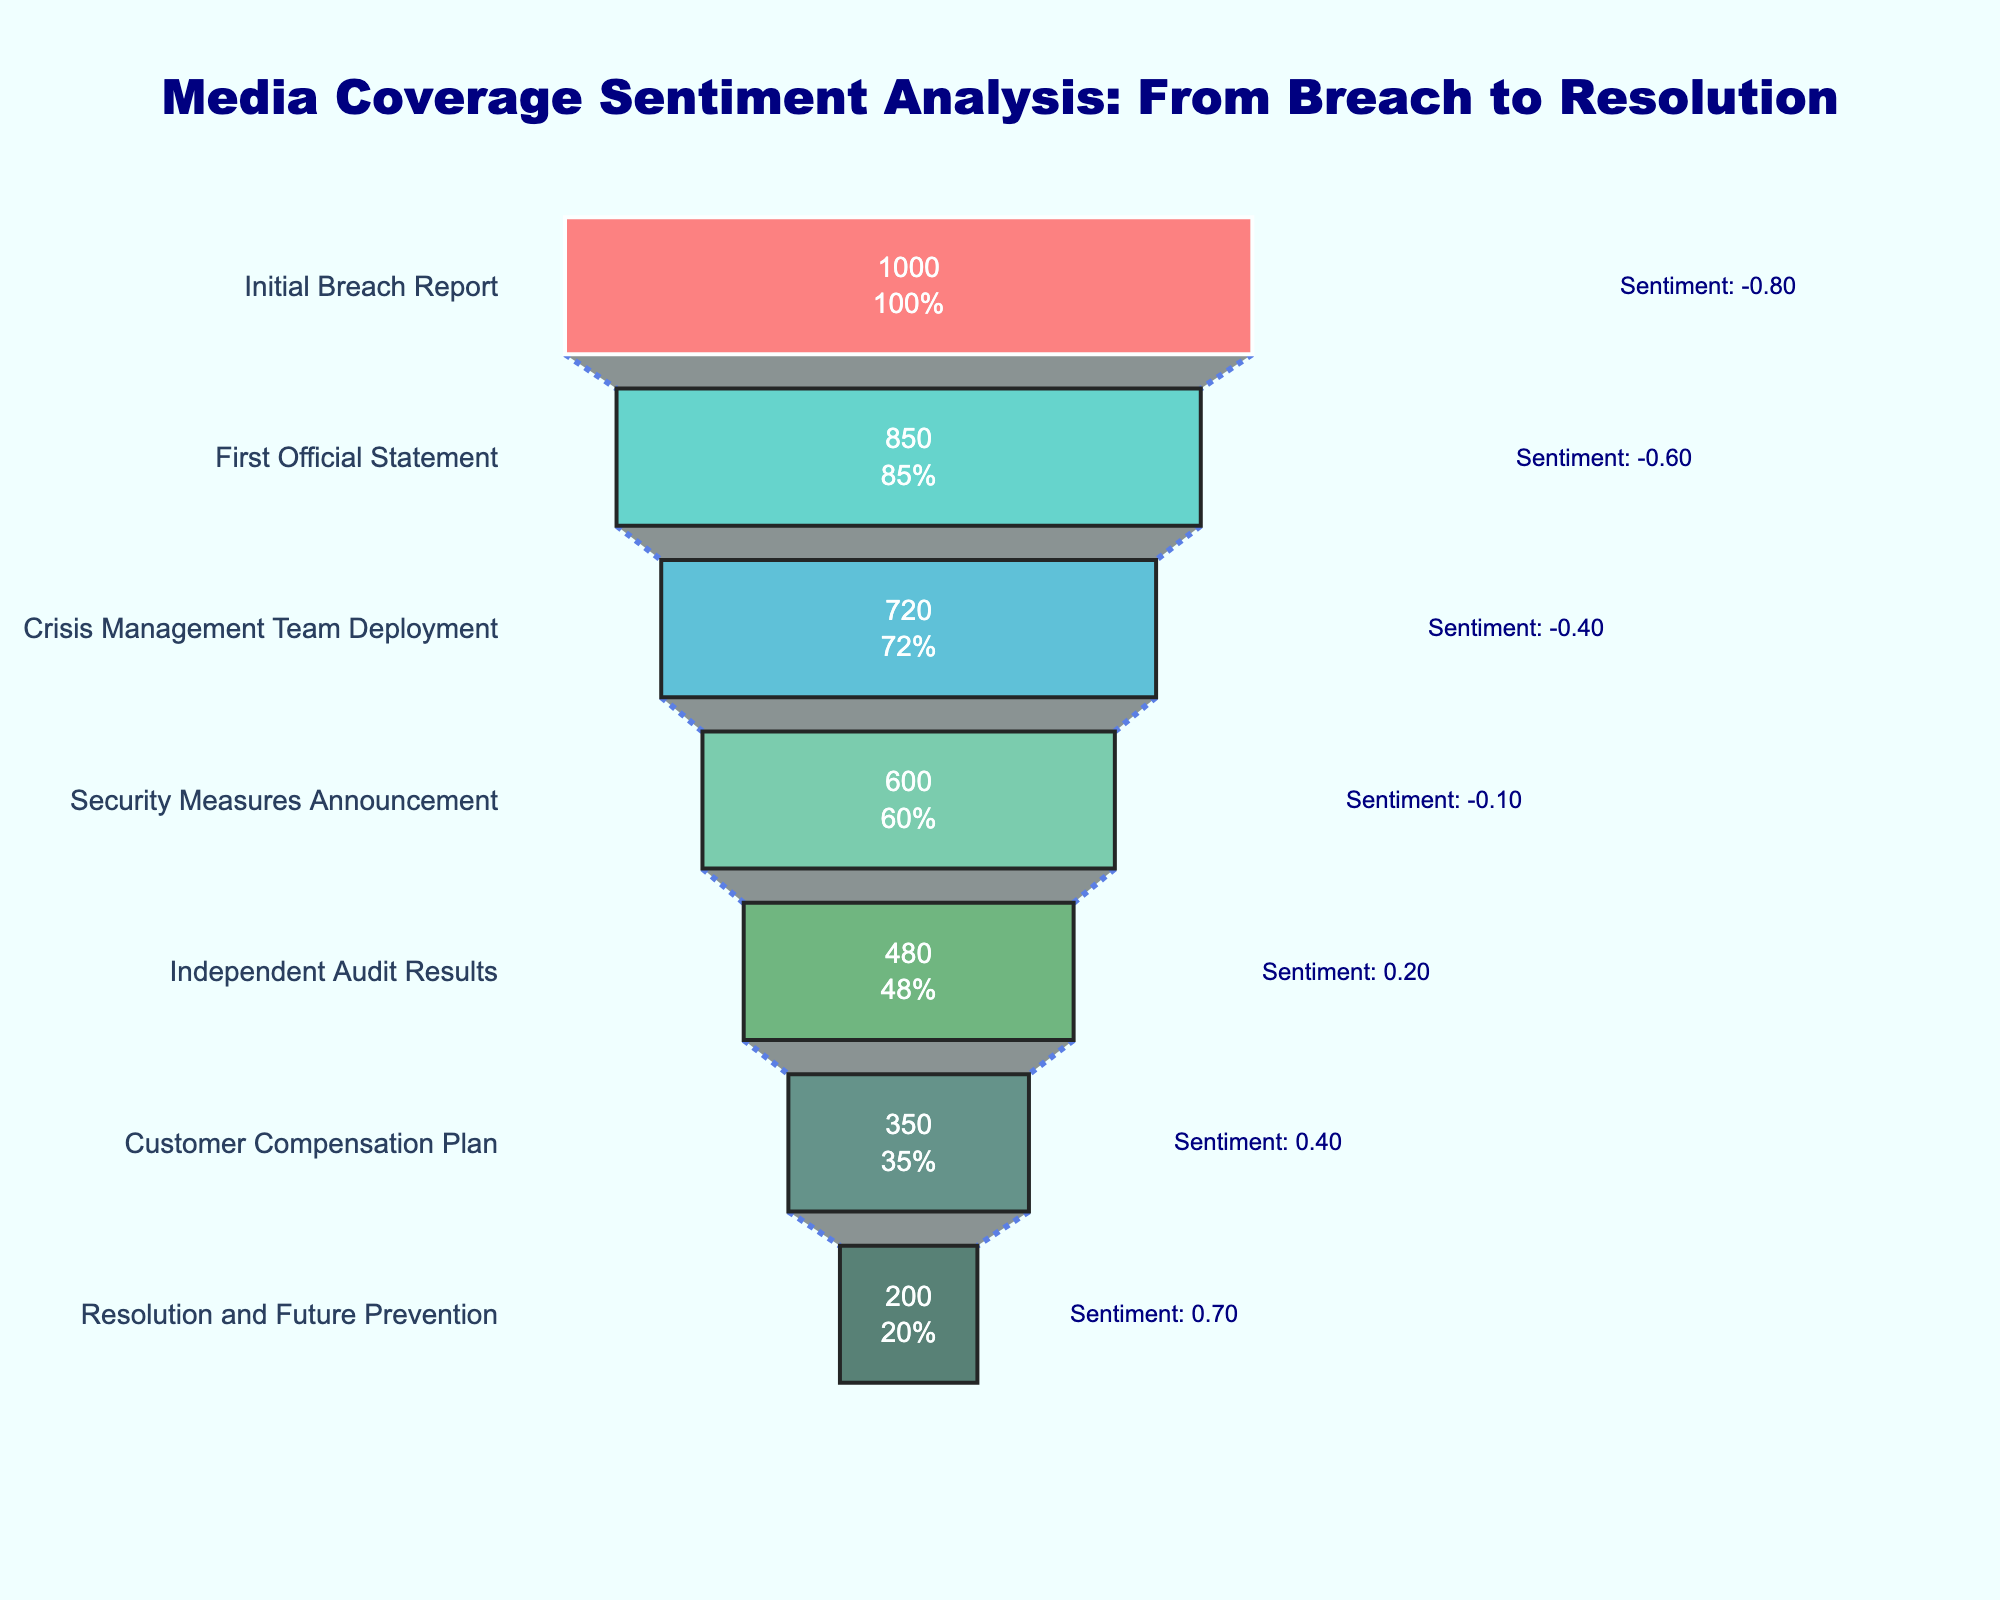How many stages are there in the funnel chart? There are seven distinct stages listed on the y-axis of the funnel chart. They are "Initial Breach Report," "First Official Statement," "Crisis Management Team Deployment," "Security Measures Announcement," "Independent Audit Results," "Customer Compensation Plan," and "Resolution and Future Prevention."
Answer: 7 What is the total number of articles mentioned across all stages? To find the total number of articles, sum the values from each stage: 1000 + 850 + 720 + 600 + 480 + 350 + 200. This results in 4200 articles.
Answer: 4200 What is the overall trend in sentiment scores from the initial breach report to the resolution? The sentiment scores increase consistently from -0.8 at the initial breach report to 0.7 at the resolution stage, indicating an improvement in sentiment over time.
Answer: Increase Which stage has the highest sentiment score? The "Resolution and Future Prevention" stage has the highest sentiment score of 0.7.
Answer: Resolution and Future Prevention At which stage does the number of articles see the most significant drop? The number of articles drops from 1000 at the "Initial Breach Report" to 850 at the "First Official Statement," a decrease of 150 articles. This is the most significant drop compared to other stages.
Answer: First Official Statement What is the percentage decrease in articles from the initial breach report to the first official statement? The percentage decrease is calculated as [(1000 - 850) / 1000] * 100%, which simplifies to 15%.
Answer: 15% Compare the sentiment scores between the "Security Measures Announcement" and the "Customer Compensation Plan." The "Security Measures Announcement" has a sentiment score of -0.1, while the "Customer Compensation Plan" has a score of 0.4. The sentiment improves by 0.5 between these two stages.
Answer: 0.5 What is the average sentiment score across all stages? Sum the sentiment scores (-0.8, -0.6, -0.4, -0.1, 0.2, 0.4, 0.7) and divide by the number of stages (7). The total is -0.6 + 0.9 = 0.3, so the average is 0.3 / 7 = 0.042857, approximately 0.04.
Answer: 0.04 How does the number of articles at the "Crisis Management Team Deployment" stage compare to the "Independent Audit Results" stage? There are 720 articles at the "Crisis Management Team Deployment" stage and 480 at the "Independent Audit Results" stage. The former has 240 more articles than the latter.
Answer: 240 